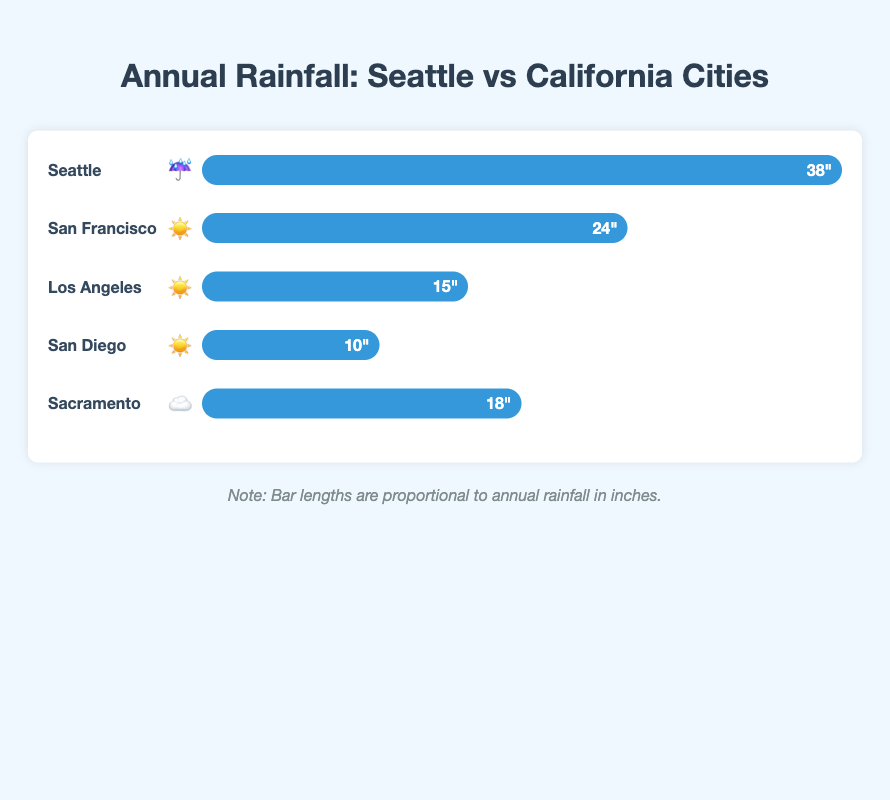What is the annual rainfall in Seattle? The bar representing Seattle has a label with "38 inches."
Answer: 38 inches Which city has the lowest annual rainfall? San Diego has the smallest bar with a label indicating "10 inches."
Answer: San Diego How much more rainfall does Seattle get compared to Los Angeles? Seattle's bar shows 38 inches, while Los Angeles has 15 inches. The difference is 38 - 15 = 23 inches.
Answer: 23 inches Arrange the cities in descending order based on their annual rainfall. Seattle (38 inches), San Francisco (24 inches), Sacramento (18 inches), Los Angeles (15 inches), San Diego (10 inches). Checking each bar label confirms this order.
Answer: Seattle, San Francisco, Sacramento, Los Angeles, San Diego Which city in California has the highest annual rainfall? Among the California cities listed, San Francisco has the highest bar with 24 inches of rainfall.
Answer: San Francisco How do the annual rainfall levels of San Francisco and Sacramento compare? San Francisco's bar shows 24 inches while Sacramento shows 18 inches. Comparing these values, San Francisco receives 6 inches more rainfall than Sacramento.
Answer: San Francisco receives 6 inches more What symbols represent Seattle and San Diego in the plot? The icon next to Seattle's name is an umbrella (☔), and the icon next to San Diego's name is a sun (☀️). These symbols are indicated next to the city names.
Answer: Seattle: umbrella (☔), San Diego: sun (☀️) What is the average annual rainfall for the listed cities? Summing the rainfall inches (38 + 24 + 15 + 10 + 18 = 105 inches) and dividing by the number of cities (5) gives 105/5 = 21 inches.
Answer: 21 inches If you combined the annual rainfall of Sacramento and San Diego, would it surpass San Francisco's rainfall? Sacramento (18 inches) combined with San Diego (10 inches) totals 18 + 10 = 28 inches, which surpasses San Francisco's 24 inches.
Answer: Yes How many inches of rain does Los Angeles get compared to San Francisco? Los Angeles receives 15 inches of rain, while San Francisco receives 24 inches. Comparing these values, Los Angeles gets 24 - 15 = 9 inches less.
Answer: 9 inches less 